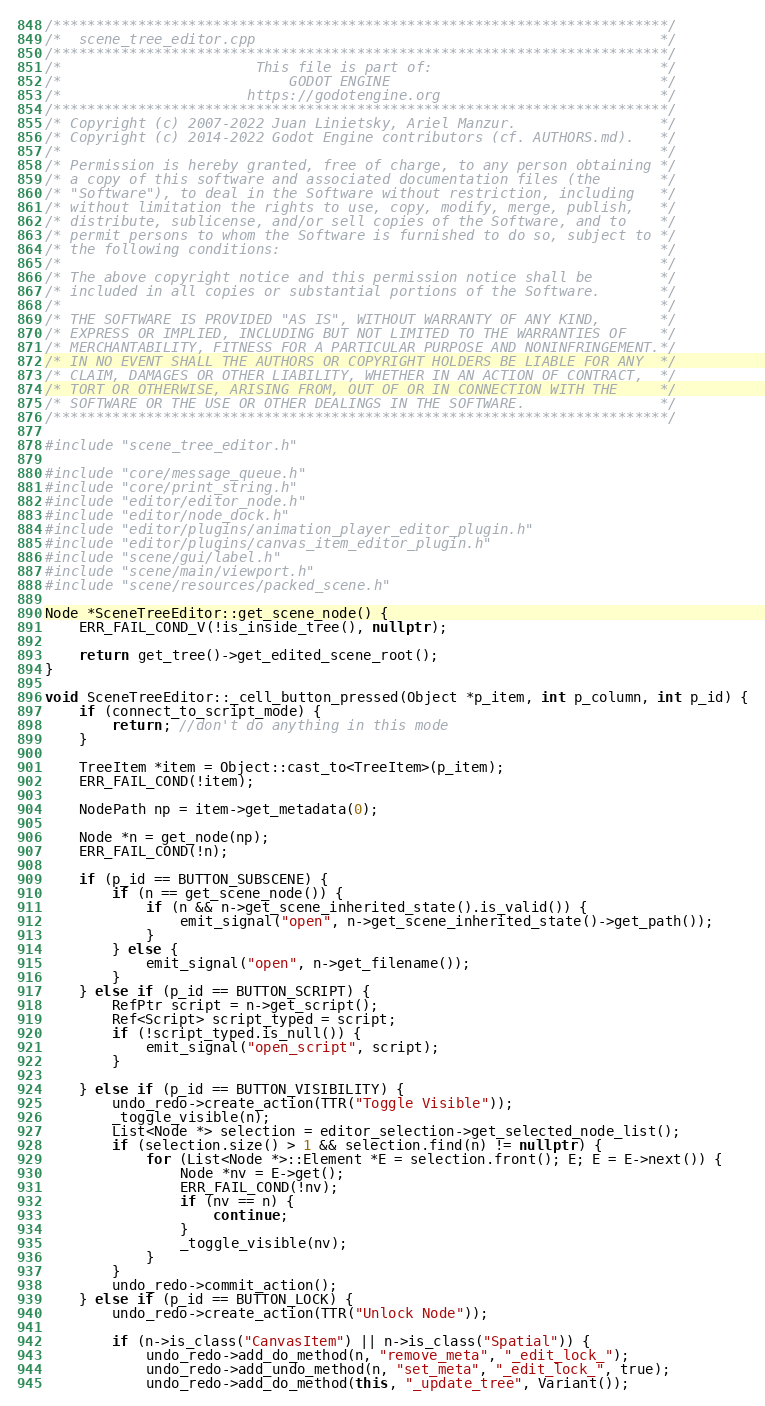<code> <loc_0><loc_0><loc_500><loc_500><_C++_>/*************************************************************************/
/*  scene_tree_editor.cpp                                                */
/*************************************************************************/
/*                       This file is part of:                           */
/*                           GODOT ENGINE                                */
/*                      https://godotengine.org                          */
/*************************************************************************/
/* Copyright (c) 2007-2022 Juan Linietsky, Ariel Manzur.                 */
/* Copyright (c) 2014-2022 Godot Engine contributors (cf. AUTHORS.md).   */
/*                                                                       */
/* Permission is hereby granted, free of charge, to any person obtaining */
/* a copy of this software and associated documentation files (the       */
/* "Software"), to deal in the Software without restriction, including   */
/* without limitation the rights to use, copy, modify, merge, publish,   */
/* distribute, sublicense, and/or sell copies of the Software, and to    */
/* permit persons to whom the Software is furnished to do so, subject to */
/* the following conditions:                                             */
/*                                                                       */
/* The above copyright notice and this permission notice shall be        */
/* included in all copies or substantial portions of the Software.       */
/*                                                                       */
/* THE SOFTWARE IS PROVIDED "AS IS", WITHOUT WARRANTY OF ANY KIND,       */
/* EXPRESS OR IMPLIED, INCLUDING BUT NOT LIMITED TO THE WARRANTIES OF    */
/* MERCHANTABILITY, FITNESS FOR A PARTICULAR PURPOSE AND NONINFRINGEMENT.*/
/* IN NO EVENT SHALL THE AUTHORS OR COPYRIGHT HOLDERS BE LIABLE FOR ANY  */
/* CLAIM, DAMAGES OR OTHER LIABILITY, WHETHER IN AN ACTION OF CONTRACT,  */
/* TORT OR OTHERWISE, ARISING FROM, OUT OF OR IN CONNECTION WITH THE     */
/* SOFTWARE OR THE USE OR OTHER DEALINGS IN THE SOFTWARE.                */
/*************************************************************************/

#include "scene_tree_editor.h"

#include "core/message_queue.h"
#include "core/print_string.h"
#include "editor/editor_node.h"
#include "editor/node_dock.h"
#include "editor/plugins/animation_player_editor_plugin.h"
#include "editor/plugins/canvas_item_editor_plugin.h"
#include "scene/gui/label.h"
#include "scene/main/viewport.h"
#include "scene/resources/packed_scene.h"

Node *SceneTreeEditor::get_scene_node() {
	ERR_FAIL_COND_V(!is_inside_tree(), nullptr);

	return get_tree()->get_edited_scene_root();
}

void SceneTreeEditor::_cell_button_pressed(Object *p_item, int p_column, int p_id) {
	if (connect_to_script_mode) {
		return; //don't do anything in this mode
	}

	TreeItem *item = Object::cast_to<TreeItem>(p_item);
	ERR_FAIL_COND(!item);

	NodePath np = item->get_metadata(0);

	Node *n = get_node(np);
	ERR_FAIL_COND(!n);

	if (p_id == BUTTON_SUBSCENE) {
		if (n == get_scene_node()) {
			if (n && n->get_scene_inherited_state().is_valid()) {
				emit_signal("open", n->get_scene_inherited_state()->get_path());
			}
		} else {
			emit_signal("open", n->get_filename());
		}
	} else if (p_id == BUTTON_SCRIPT) {
		RefPtr script = n->get_script();
		Ref<Script> script_typed = script;
		if (!script_typed.is_null()) {
			emit_signal("open_script", script);
		}

	} else if (p_id == BUTTON_VISIBILITY) {
		undo_redo->create_action(TTR("Toggle Visible"));
		_toggle_visible(n);
		List<Node *> selection = editor_selection->get_selected_node_list();
		if (selection.size() > 1 && selection.find(n) != nullptr) {
			for (List<Node *>::Element *E = selection.front(); E; E = E->next()) {
				Node *nv = E->get();
				ERR_FAIL_COND(!nv);
				if (nv == n) {
					continue;
				}
				_toggle_visible(nv);
			}
		}
		undo_redo->commit_action();
	} else if (p_id == BUTTON_LOCK) {
		undo_redo->create_action(TTR("Unlock Node"));

		if (n->is_class("CanvasItem") || n->is_class("Spatial")) {
			undo_redo->add_do_method(n, "remove_meta", "_edit_lock_");
			undo_redo->add_undo_method(n, "set_meta", "_edit_lock_", true);
			undo_redo->add_do_method(this, "_update_tree", Variant());</code> 